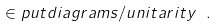Convert formula to latex. <formula><loc_0><loc_0><loc_500><loc_500>\in p u t { d i a g r a m s / u n i t a r i t y } \ .</formula> 